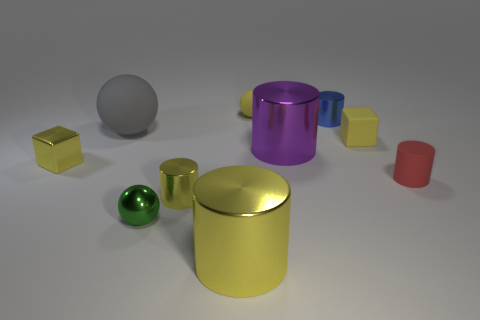Do the tiny shiny cube and the small rubber ball have the same color?
Your response must be concise. Yes. Is there a small shiny ball?
Ensure brevity in your answer.  Yes. How many yellow rubber spheres have the same size as the purple cylinder?
Your answer should be compact. 0. Is the number of large purple metal objects behind the big gray rubber thing greater than the number of yellow shiny cubes right of the tiny rubber cylinder?
Keep it short and to the point. No. There is a purple cylinder that is the same size as the gray thing; what material is it?
Keep it short and to the point. Metal. There is a red object; what shape is it?
Give a very brief answer. Cylinder. What number of gray things are either large matte things or shiny balls?
Give a very brief answer. 1. The purple thing that is made of the same material as the small green thing is what size?
Give a very brief answer. Large. Does the large cylinder that is to the left of the tiny yellow ball have the same material as the small yellow object that is right of the tiny rubber sphere?
Your answer should be compact. No. What number of cylinders are either cyan metal things or large yellow metallic things?
Ensure brevity in your answer.  1. 